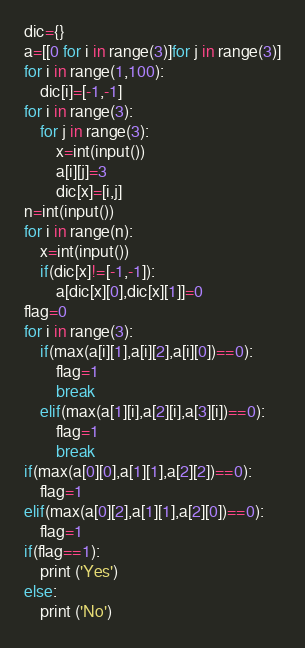Convert code to text. <code><loc_0><loc_0><loc_500><loc_500><_Python_>dic={}
a=[[0 for i in range(3)]for j in range(3)]
for i in range(1,100):
    dic[i]=[-1,-1]
for i in range(3):
    for j in range(3):
        x=int(input())
        a[i][j]=3
        dic[x]=[i,j]
n=int(input())
for i in range(n):
    x=int(input())
    if(dic[x]!=[-1,-1]):
        a[dic[x][0],dic[x][1]]=0
flag=0
for i in range(3):
    if(max(a[i][1],a[i][2],a[i][0])==0):
        flag=1
        break
    elif(max(a[1][i],a[2][i],a[3][i])==0):
        flag=1
        break
if(max(a[0][0],a[1][1],a[2][2])==0):
    flag=1
elif(max(a[0][2],a[1][1],a[2][0])==0):
    flag=1
if(flag==1):
    print ('Yes')
else:
    print ('No')</code> 